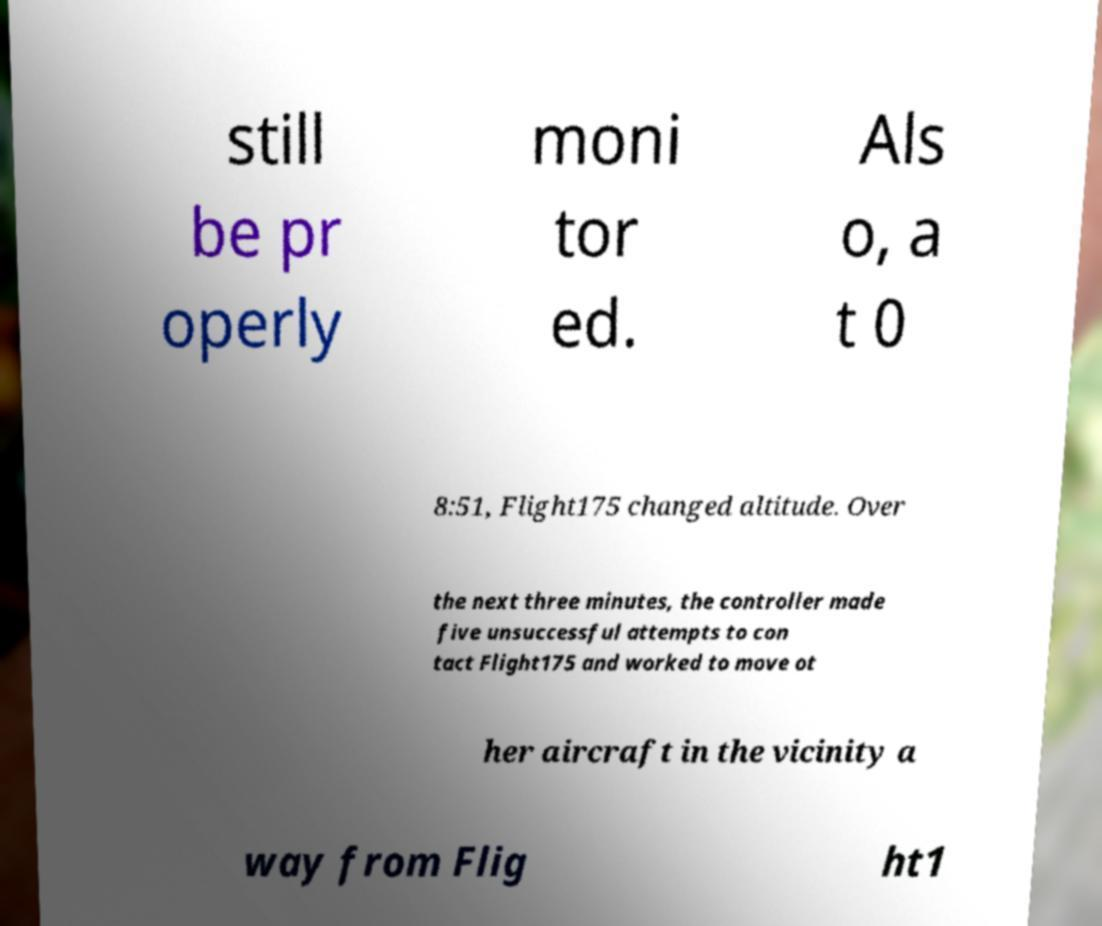For documentation purposes, I need the text within this image transcribed. Could you provide that? still be pr operly moni tor ed. Als o, a t 0 8:51, Flight175 changed altitude. Over the next three minutes, the controller made five unsuccessful attempts to con tact Flight175 and worked to move ot her aircraft in the vicinity a way from Flig ht1 